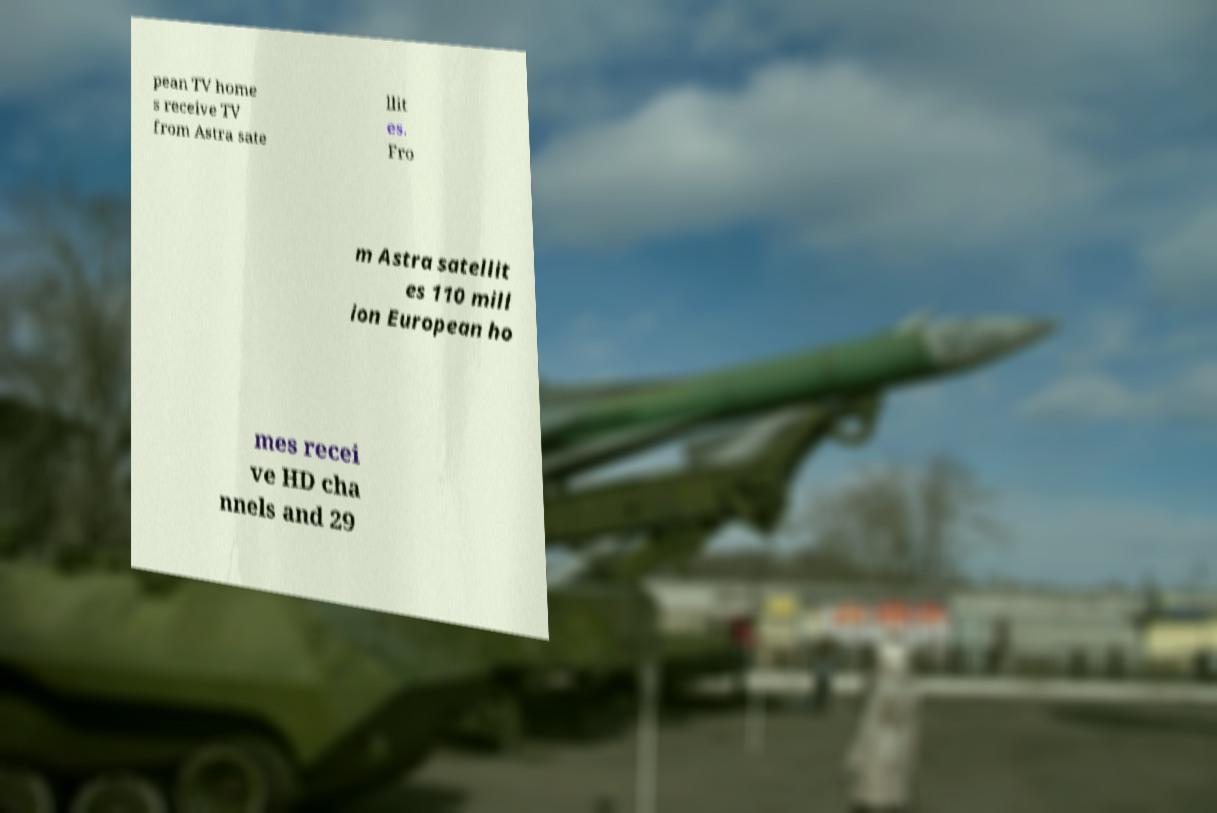Could you extract and type out the text from this image? pean TV home s receive TV from Astra sate llit es. Fro m Astra satellit es 110 mill ion European ho mes recei ve HD cha nnels and 29 